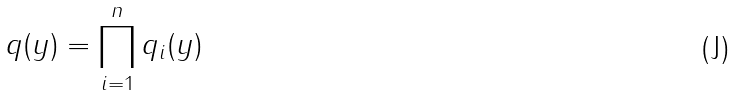<formula> <loc_0><loc_0><loc_500><loc_500>q ( y ) = \prod _ { i = 1 } ^ { n } q _ { i } ( y )</formula> 